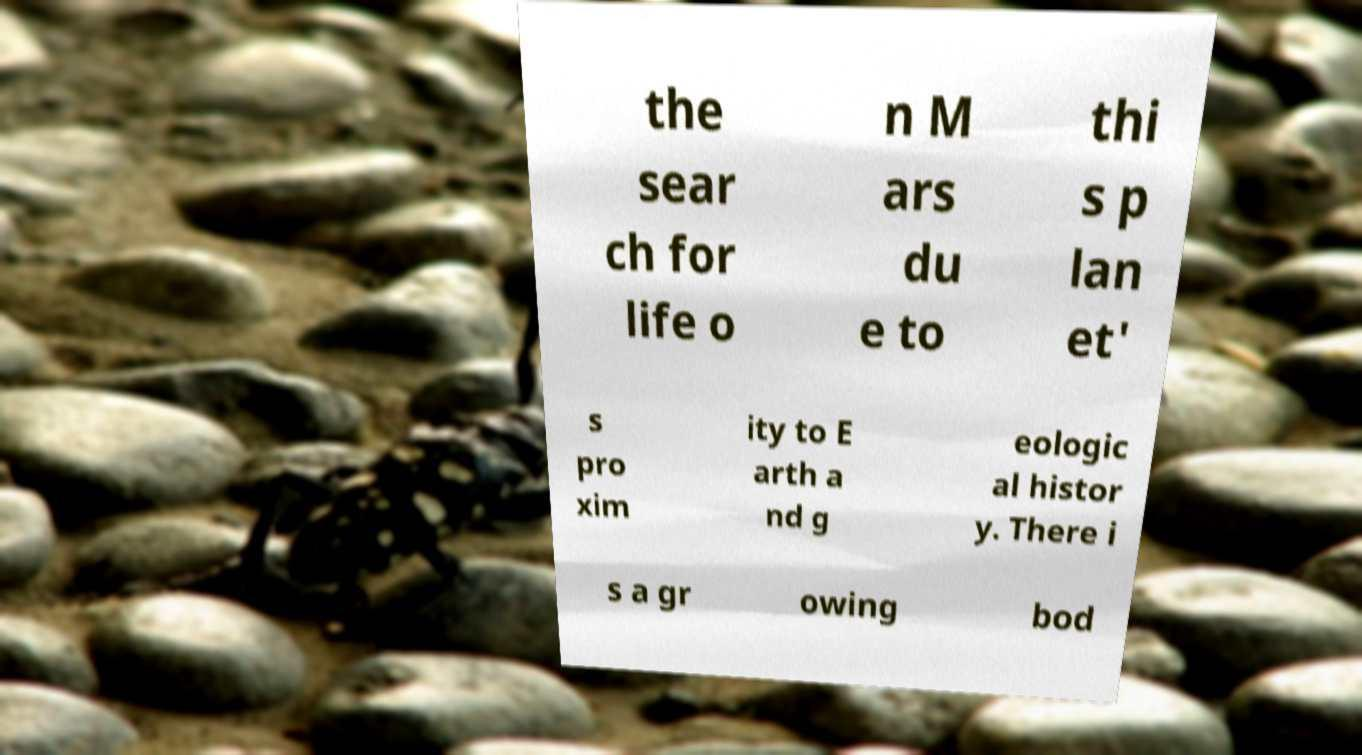For documentation purposes, I need the text within this image transcribed. Could you provide that? the sear ch for life o n M ars du e to thi s p lan et' s pro xim ity to E arth a nd g eologic al histor y. There i s a gr owing bod 